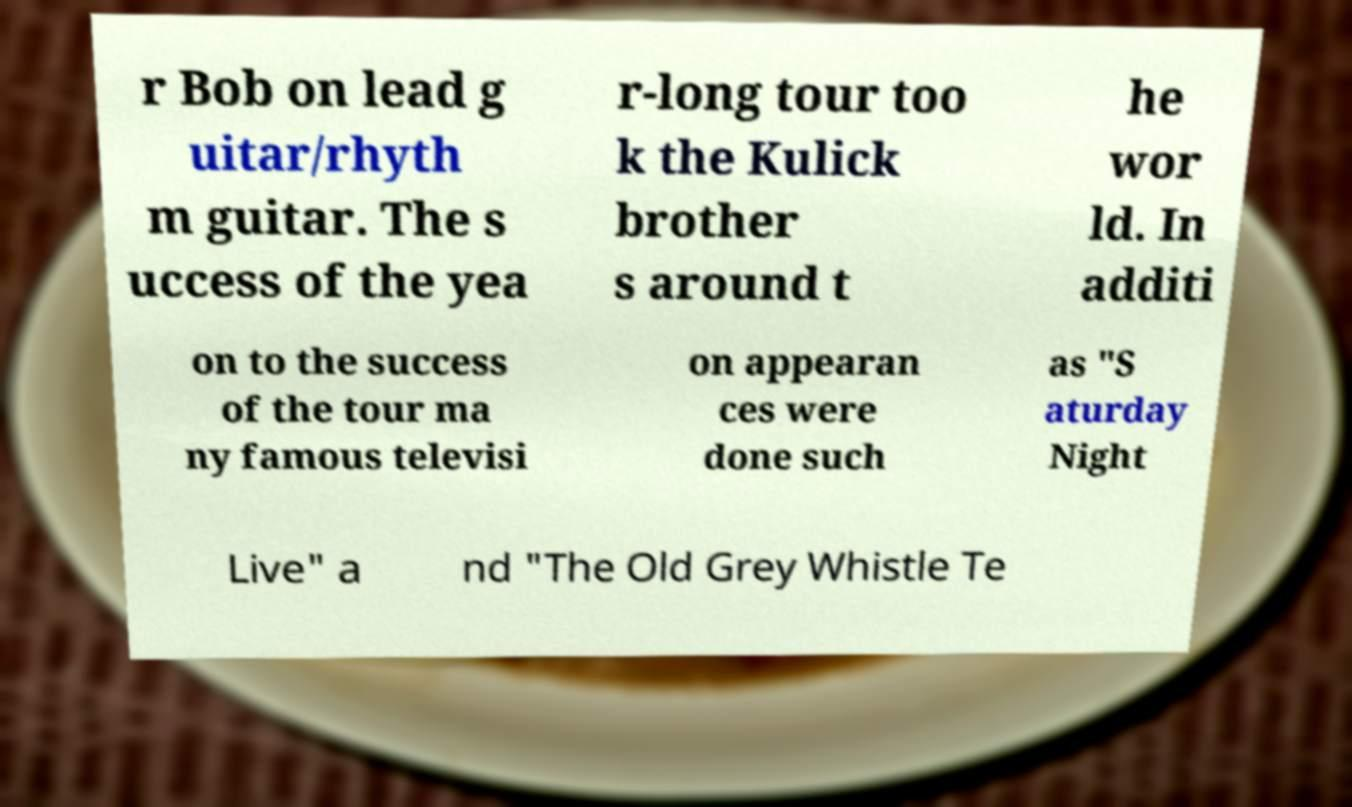Please identify and transcribe the text found in this image. r Bob on lead g uitar/rhyth m guitar. The s uccess of the yea r-long tour too k the Kulick brother s around t he wor ld. In additi on to the success of the tour ma ny famous televisi on appearan ces were done such as "S aturday Night Live" a nd "The Old Grey Whistle Te 